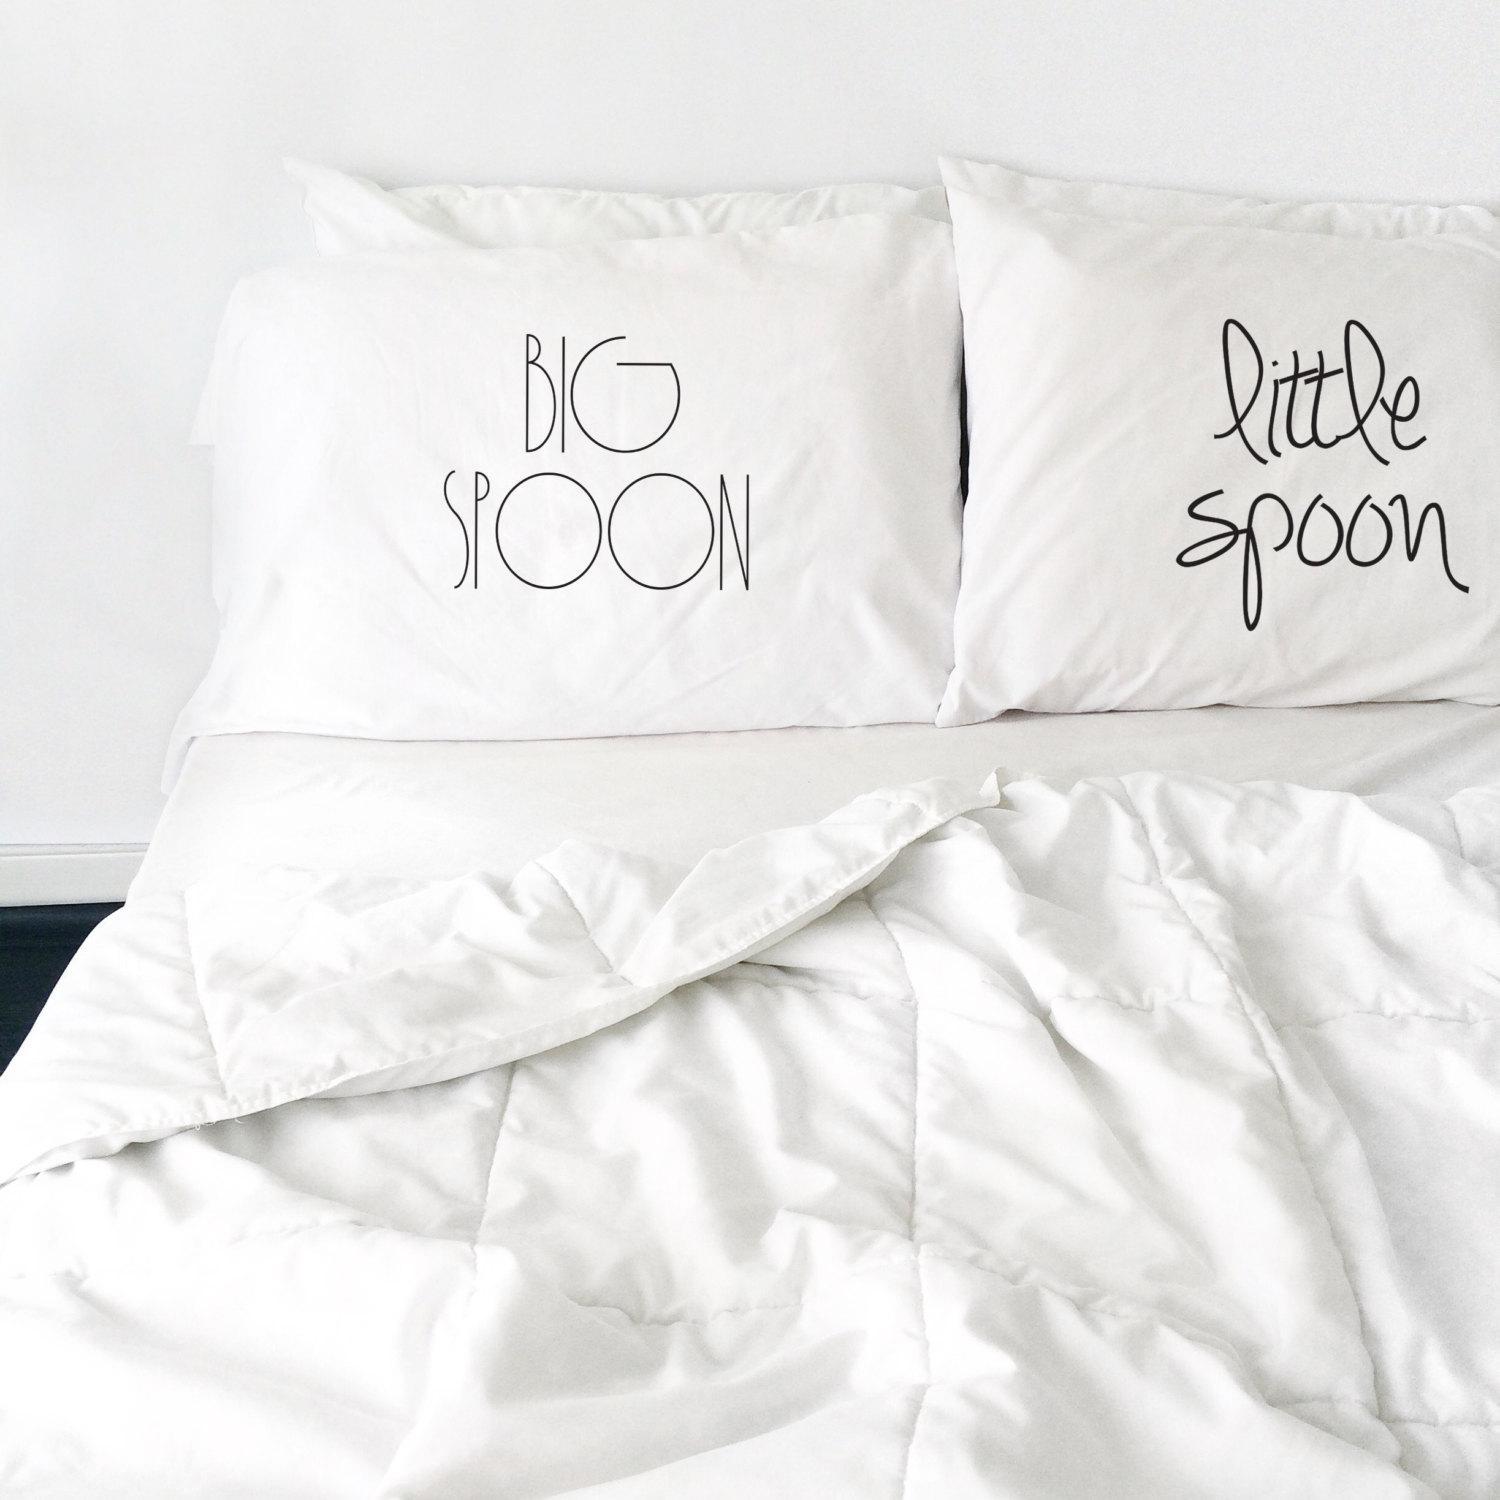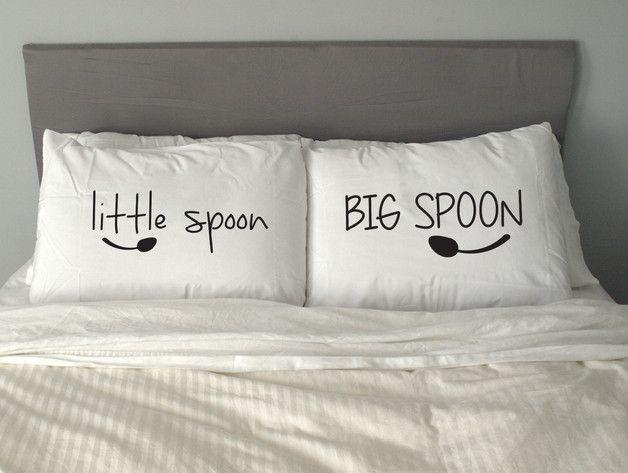The first image is the image on the left, the second image is the image on the right. Assess this claim about the two images: "A pair of pillows are side-by-side on a bed and printed with spoon shapes below lettering.". Correct or not? Answer yes or no. Yes. The first image is the image on the left, the second image is the image on the right. For the images displayed, is the sentence "Each image shows a set of white pillows angled upward at the head of a bed, each set with the same saying but a different letter design." factually correct? Answer yes or no. Yes. 